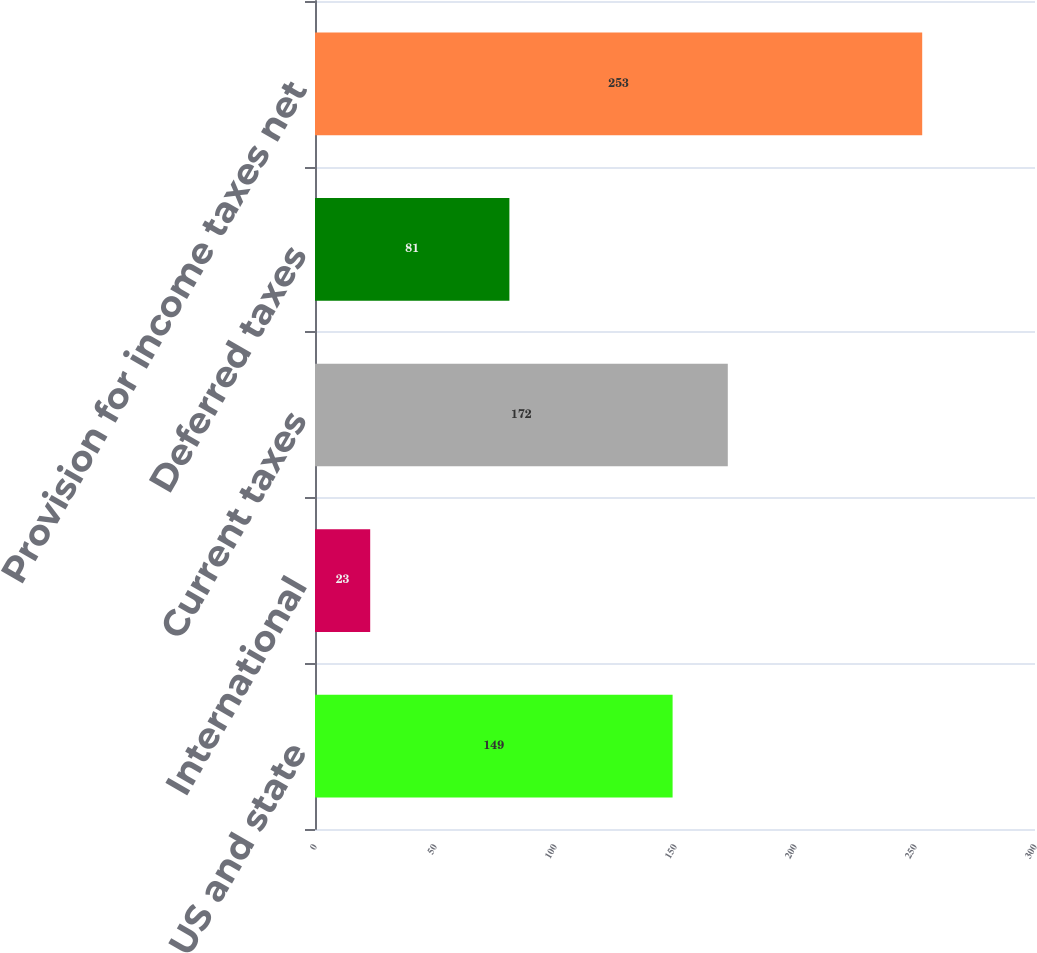Convert chart. <chart><loc_0><loc_0><loc_500><loc_500><bar_chart><fcel>US and state<fcel>International<fcel>Current taxes<fcel>Deferred taxes<fcel>Provision for income taxes net<nl><fcel>149<fcel>23<fcel>172<fcel>81<fcel>253<nl></chart> 